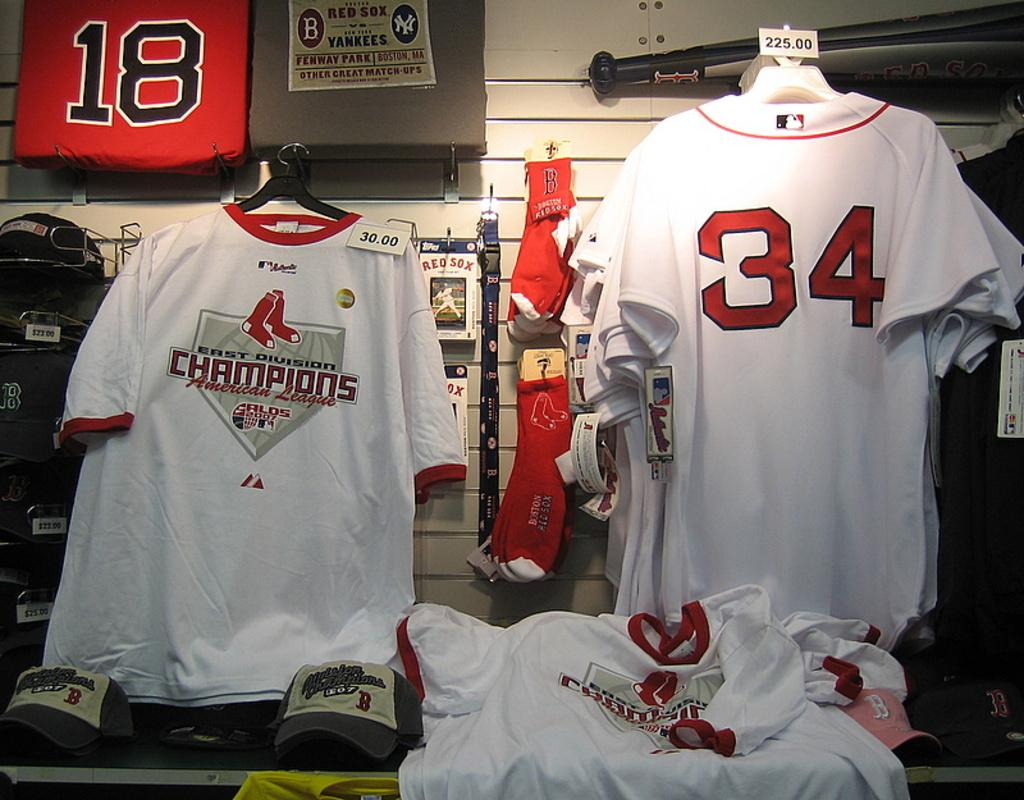<image>
Present a compact description of the photo's key features. Some white East Division Champions American League jerseys. 